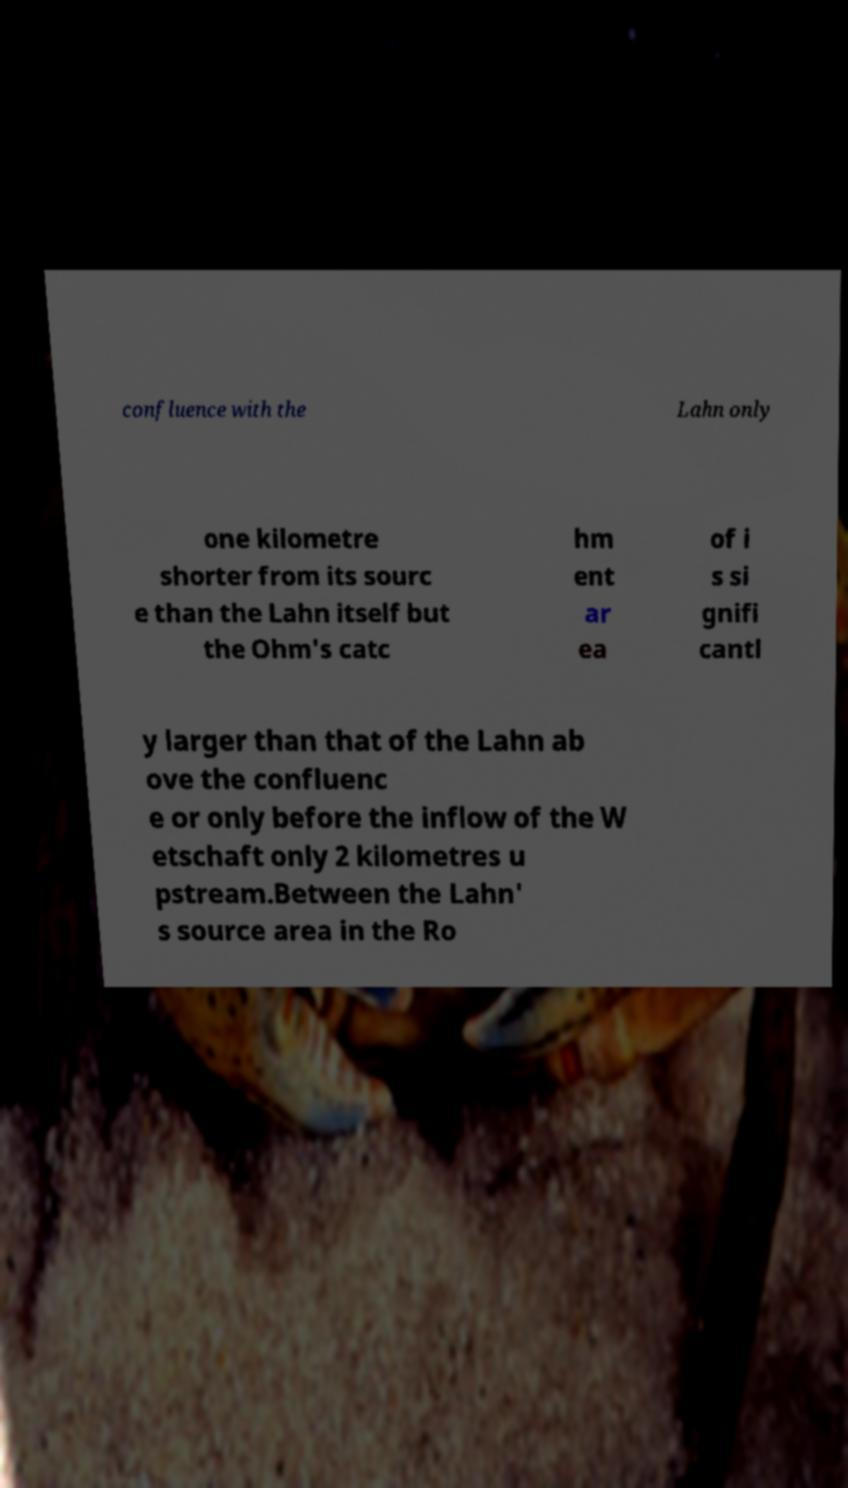Could you extract and type out the text from this image? confluence with the Lahn only one kilometre shorter from its sourc e than the Lahn itself but the Ohm's catc hm ent ar ea of i s si gnifi cantl y larger than that of the Lahn ab ove the confluenc e or only before the inflow of the W etschaft only 2 kilometres u pstream.Between the Lahn' s source area in the Ro 